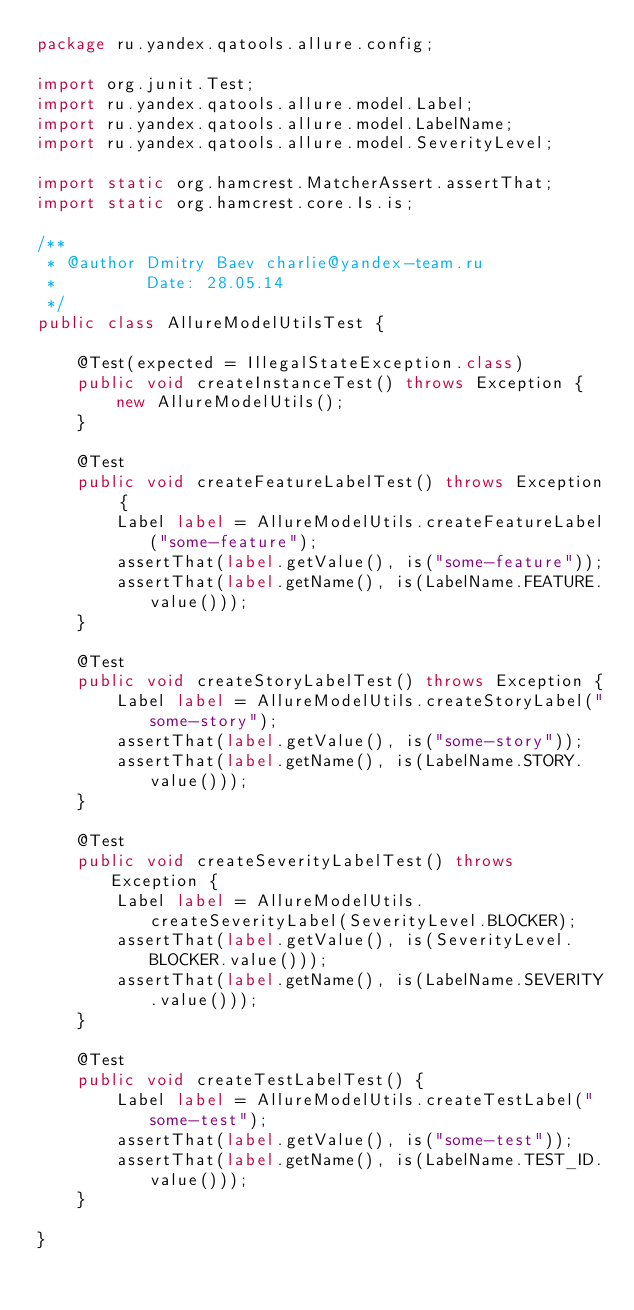Convert code to text. <code><loc_0><loc_0><loc_500><loc_500><_Java_>package ru.yandex.qatools.allure.config;

import org.junit.Test;
import ru.yandex.qatools.allure.model.Label;
import ru.yandex.qatools.allure.model.LabelName;
import ru.yandex.qatools.allure.model.SeverityLevel;

import static org.hamcrest.MatcherAssert.assertThat;
import static org.hamcrest.core.Is.is;

/**
 * @author Dmitry Baev charlie@yandex-team.ru
 *         Date: 28.05.14
 */
public class AllureModelUtilsTest {

    @Test(expected = IllegalStateException.class)
    public void createInstanceTest() throws Exception {
        new AllureModelUtils();
    }

    @Test
    public void createFeatureLabelTest() throws Exception {
        Label label = AllureModelUtils.createFeatureLabel("some-feature");
        assertThat(label.getValue(), is("some-feature"));
        assertThat(label.getName(), is(LabelName.FEATURE.value()));
    }

    @Test
    public void createStoryLabelTest() throws Exception {
        Label label = AllureModelUtils.createStoryLabel("some-story");
        assertThat(label.getValue(), is("some-story"));
        assertThat(label.getName(), is(LabelName.STORY.value()));
    }

    @Test
    public void createSeverityLabelTest() throws Exception {
        Label label = AllureModelUtils.createSeverityLabel(SeverityLevel.BLOCKER);
        assertThat(label.getValue(), is(SeverityLevel.BLOCKER.value()));
        assertThat(label.getName(), is(LabelName.SEVERITY.value()));
    }

    @Test
    public void createTestLabelTest() {
        Label label = AllureModelUtils.createTestLabel("some-test");
        assertThat(label.getValue(), is("some-test"));
        assertThat(label.getName(), is(LabelName.TEST_ID.value()));
    }

}
</code> 